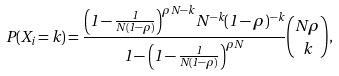Convert formula to latex. <formula><loc_0><loc_0><loc_500><loc_500>P ( X _ { i } = k ) = { \frac { \left ( 1 - { \frac { 1 } { N ( 1 - \rho ) } } \right ) ^ { \rho N - k } N ^ { - k } ( 1 - \rho ) ^ { - k } } { 1 - \left ( 1 - { \frac { 1 } { N ( 1 - \rho ) } } \right ) ^ { \rho N } } } { { N \rho } \choose k } ,</formula> 